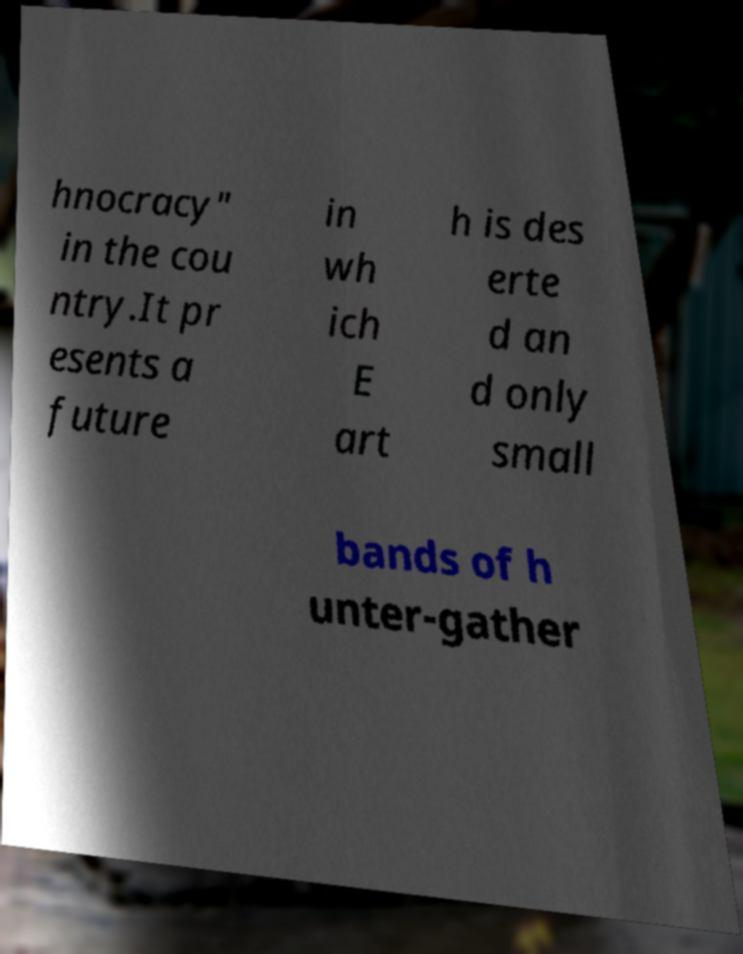For documentation purposes, I need the text within this image transcribed. Could you provide that? hnocracy" in the cou ntry.It pr esents a future in wh ich E art h is des erte d an d only small bands of h unter-gather 